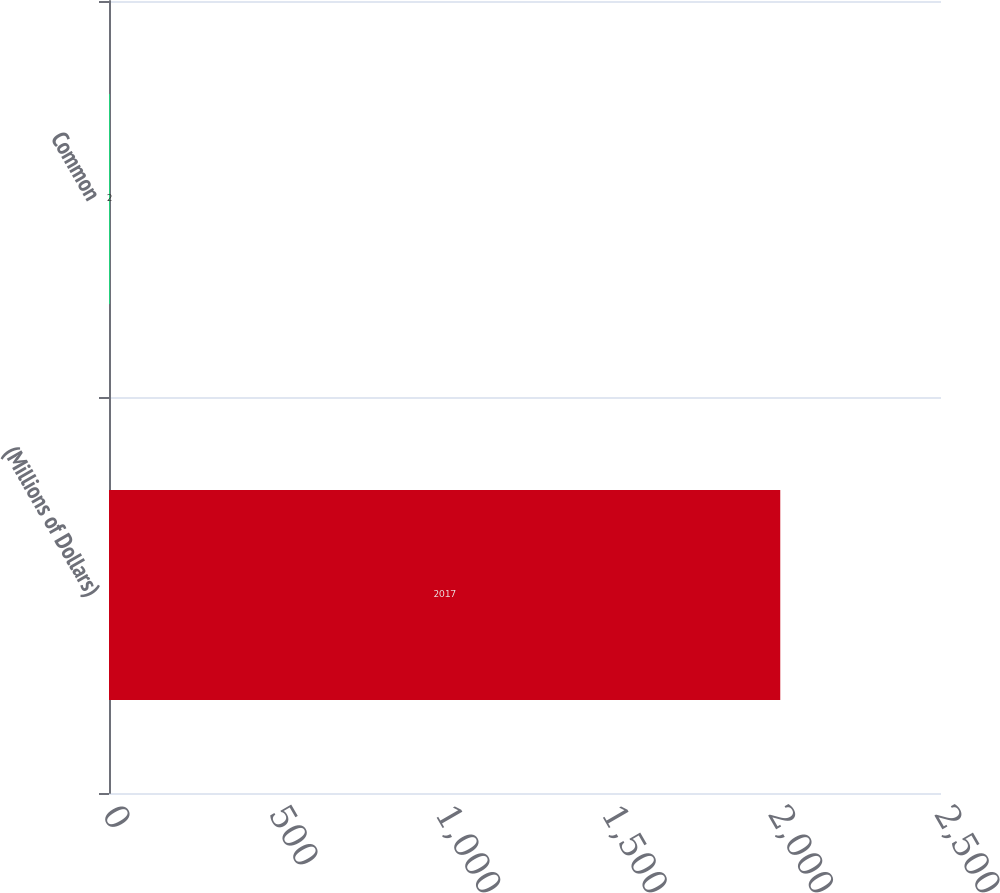Convert chart to OTSL. <chart><loc_0><loc_0><loc_500><loc_500><bar_chart><fcel>(Millions of Dollars)<fcel>Common<nl><fcel>2017<fcel>2<nl></chart> 